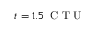<formula> <loc_0><loc_0><loc_500><loc_500>t = 1 . 5 \, C T U</formula> 